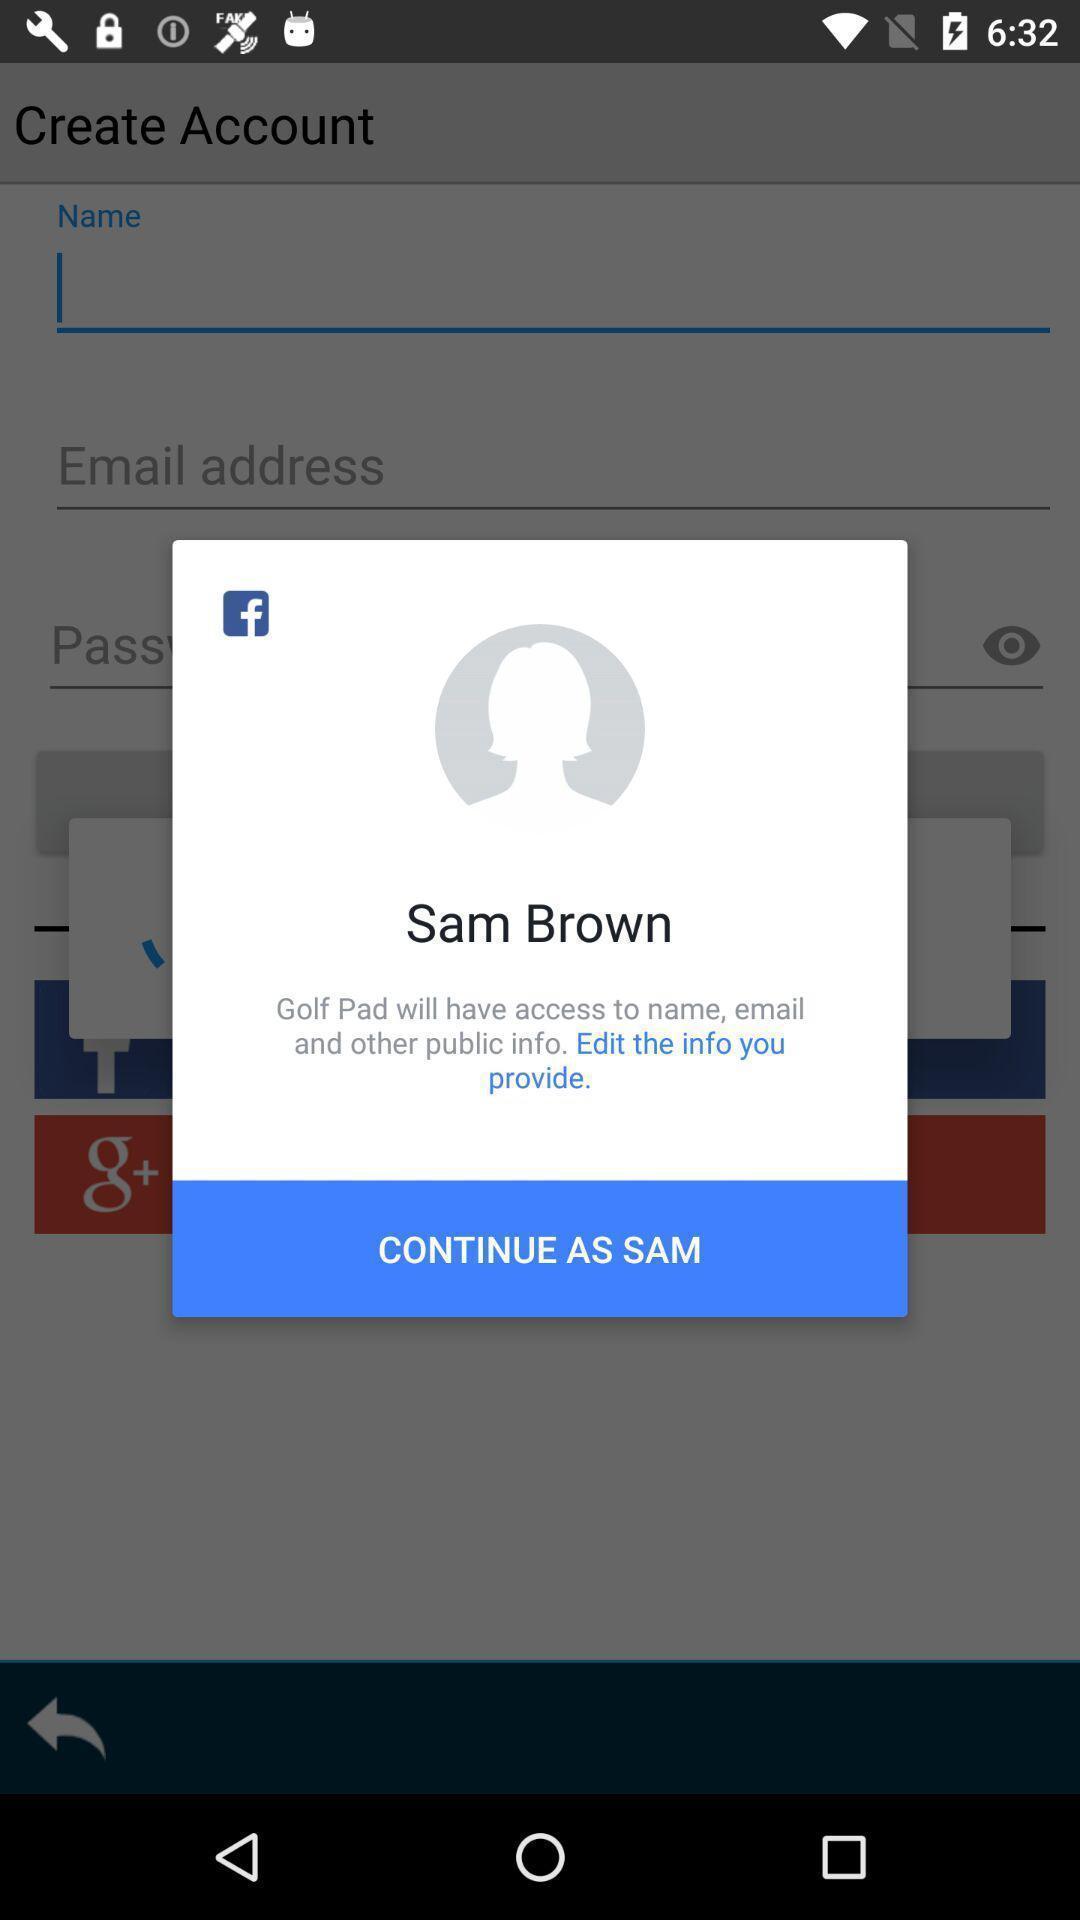What details can you identify in this image? Pop-up showing to continue as info provided. 